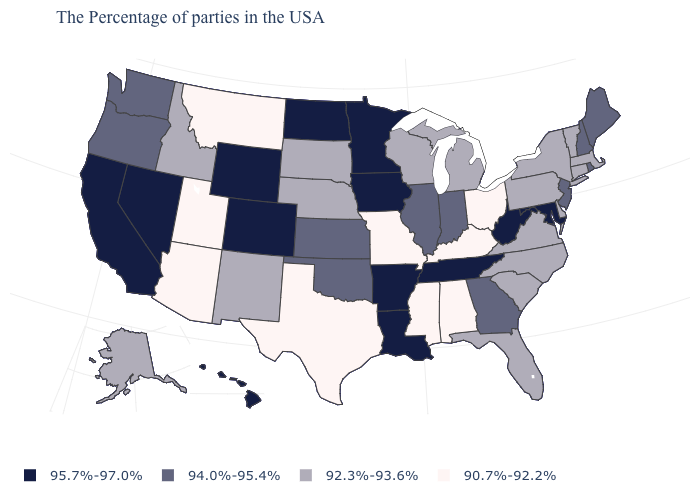Name the states that have a value in the range 95.7%-97.0%?
Keep it brief. Maryland, West Virginia, Tennessee, Louisiana, Arkansas, Minnesota, Iowa, North Dakota, Wyoming, Colorado, Nevada, California, Hawaii. What is the highest value in the USA?
Keep it brief. 95.7%-97.0%. Name the states that have a value in the range 92.3%-93.6%?
Answer briefly. Massachusetts, Vermont, Connecticut, New York, Delaware, Pennsylvania, Virginia, North Carolina, South Carolina, Florida, Michigan, Wisconsin, Nebraska, South Dakota, New Mexico, Idaho, Alaska. What is the lowest value in the USA?
Keep it brief. 90.7%-92.2%. What is the value of Washington?
Quick response, please. 94.0%-95.4%. What is the value of South Carolina?
Quick response, please. 92.3%-93.6%. Does Kentucky have the lowest value in the USA?
Quick response, please. Yes. Does Delaware have the lowest value in the USA?
Write a very short answer. No. What is the lowest value in the USA?
Give a very brief answer. 90.7%-92.2%. Which states have the lowest value in the USA?
Give a very brief answer. Ohio, Kentucky, Alabama, Mississippi, Missouri, Texas, Utah, Montana, Arizona. Does Delaware have the same value as Utah?
Write a very short answer. No. Which states hav the highest value in the MidWest?
Be succinct. Minnesota, Iowa, North Dakota. What is the highest value in states that border Pennsylvania?
Keep it brief. 95.7%-97.0%. Name the states that have a value in the range 92.3%-93.6%?
Give a very brief answer. Massachusetts, Vermont, Connecticut, New York, Delaware, Pennsylvania, Virginia, North Carolina, South Carolina, Florida, Michigan, Wisconsin, Nebraska, South Dakota, New Mexico, Idaho, Alaska. What is the highest value in the USA?
Answer briefly. 95.7%-97.0%. 